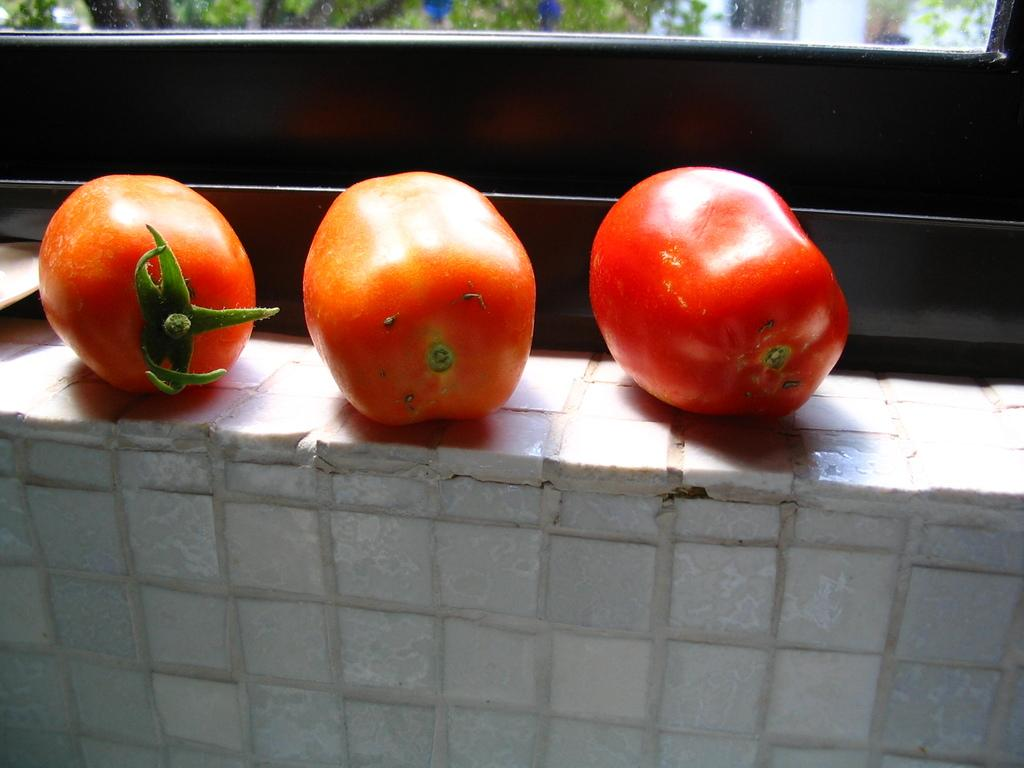What is the main subject in the center of the image? There are tomatoes in the center of the image. What is the tomatoes placed on? The tomatoes are placed on an object. What can be seen in the background of the image? There is a window in the background of the image. What is visible through the window? The outside view is visible through the window. How many copies of the tomatoes can be seen in the image? There is only one set of tomatoes visible in the image, so there are no copies. 